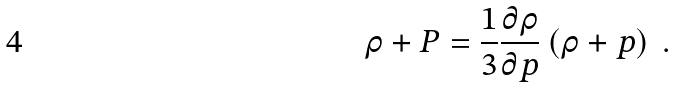<formula> <loc_0><loc_0><loc_500><loc_500>\rho + P = \frac { 1 } { 3 } \frac { \partial \rho } { \partial p } \left ( \rho + p \right ) \ .</formula> 